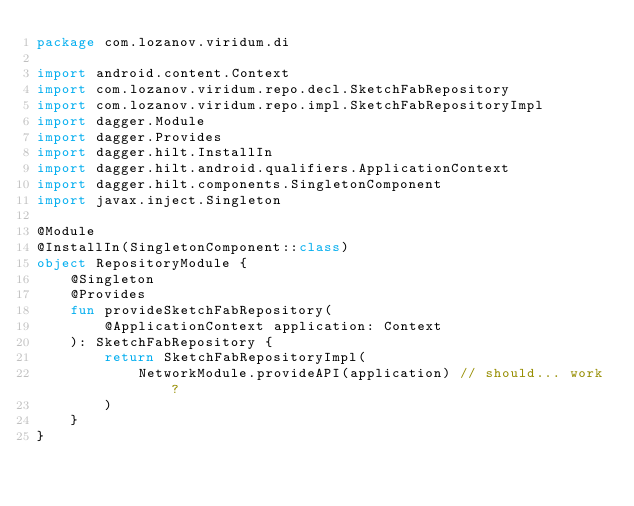<code> <loc_0><loc_0><loc_500><loc_500><_Kotlin_>package com.lozanov.viridum.di

import android.content.Context
import com.lozanov.viridum.repo.decl.SketchFabRepository
import com.lozanov.viridum.repo.impl.SketchFabRepositoryImpl
import dagger.Module
import dagger.Provides
import dagger.hilt.InstallIn
import dagger.hilt.android.qualifiers.ApplicationContext
import dagger.hilt.components.SingletonComponent
import javax.inject.Singleton

@Module
@InstallIn(SingletonComponent::class)
object RepositoryModule {
    @Singleton
    @Provides
    fun provideSketchFabRepository(
        @ApplicationContext application: Context
    ): SketchFabRepository {
        return SketchFabRepositoryImpl(
            NetworkModule.provideAPI(application) // should... work?
        )
    }
}</code> 